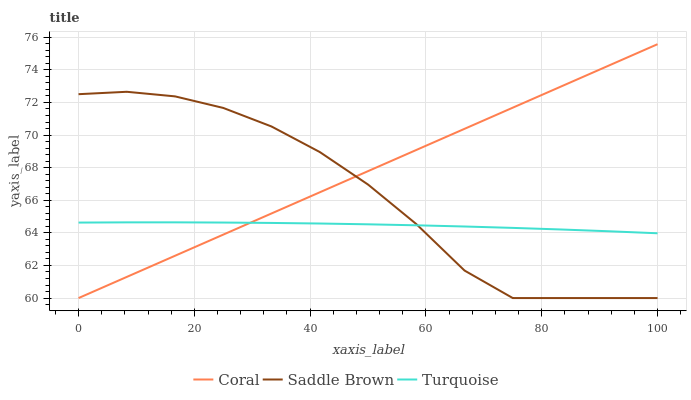Does Turquoise have the minimum area under the curve?
Answer yes or no. Yes. Does Coral have the maximum area under the curve?
Answer yes or no. Yes. Does Saddle Brown have the minimum area under the curve?
Answer yes or no. No. Does Saddle Brown have the maximum area under the curve?
Answer yes or no. No. Is Coral the smoothest?
Answer yes or no. Yes. Is Saddle Brown the roughest?
Answer yes or no. Yes. Is Turquoise the smoothest?
Answer yes or no. No. Is Turquoise the roughest?
Answer yes or no. No. Does Turquoise have the lowest value?
Answer yes or no. No. Does Coral have the highest value?
Answer yes or no. Yes. Does Saddle Brown have the highest value?
Answer yes or no. No. Does Turquoise intersect Saddle Brown?
Answer yes or no. Yes. Is Turquoise less than Saddle Brown?
Answer yes or no. No. Is Turquoise greater than Saddle Brown?
Answer yes or no. No. 